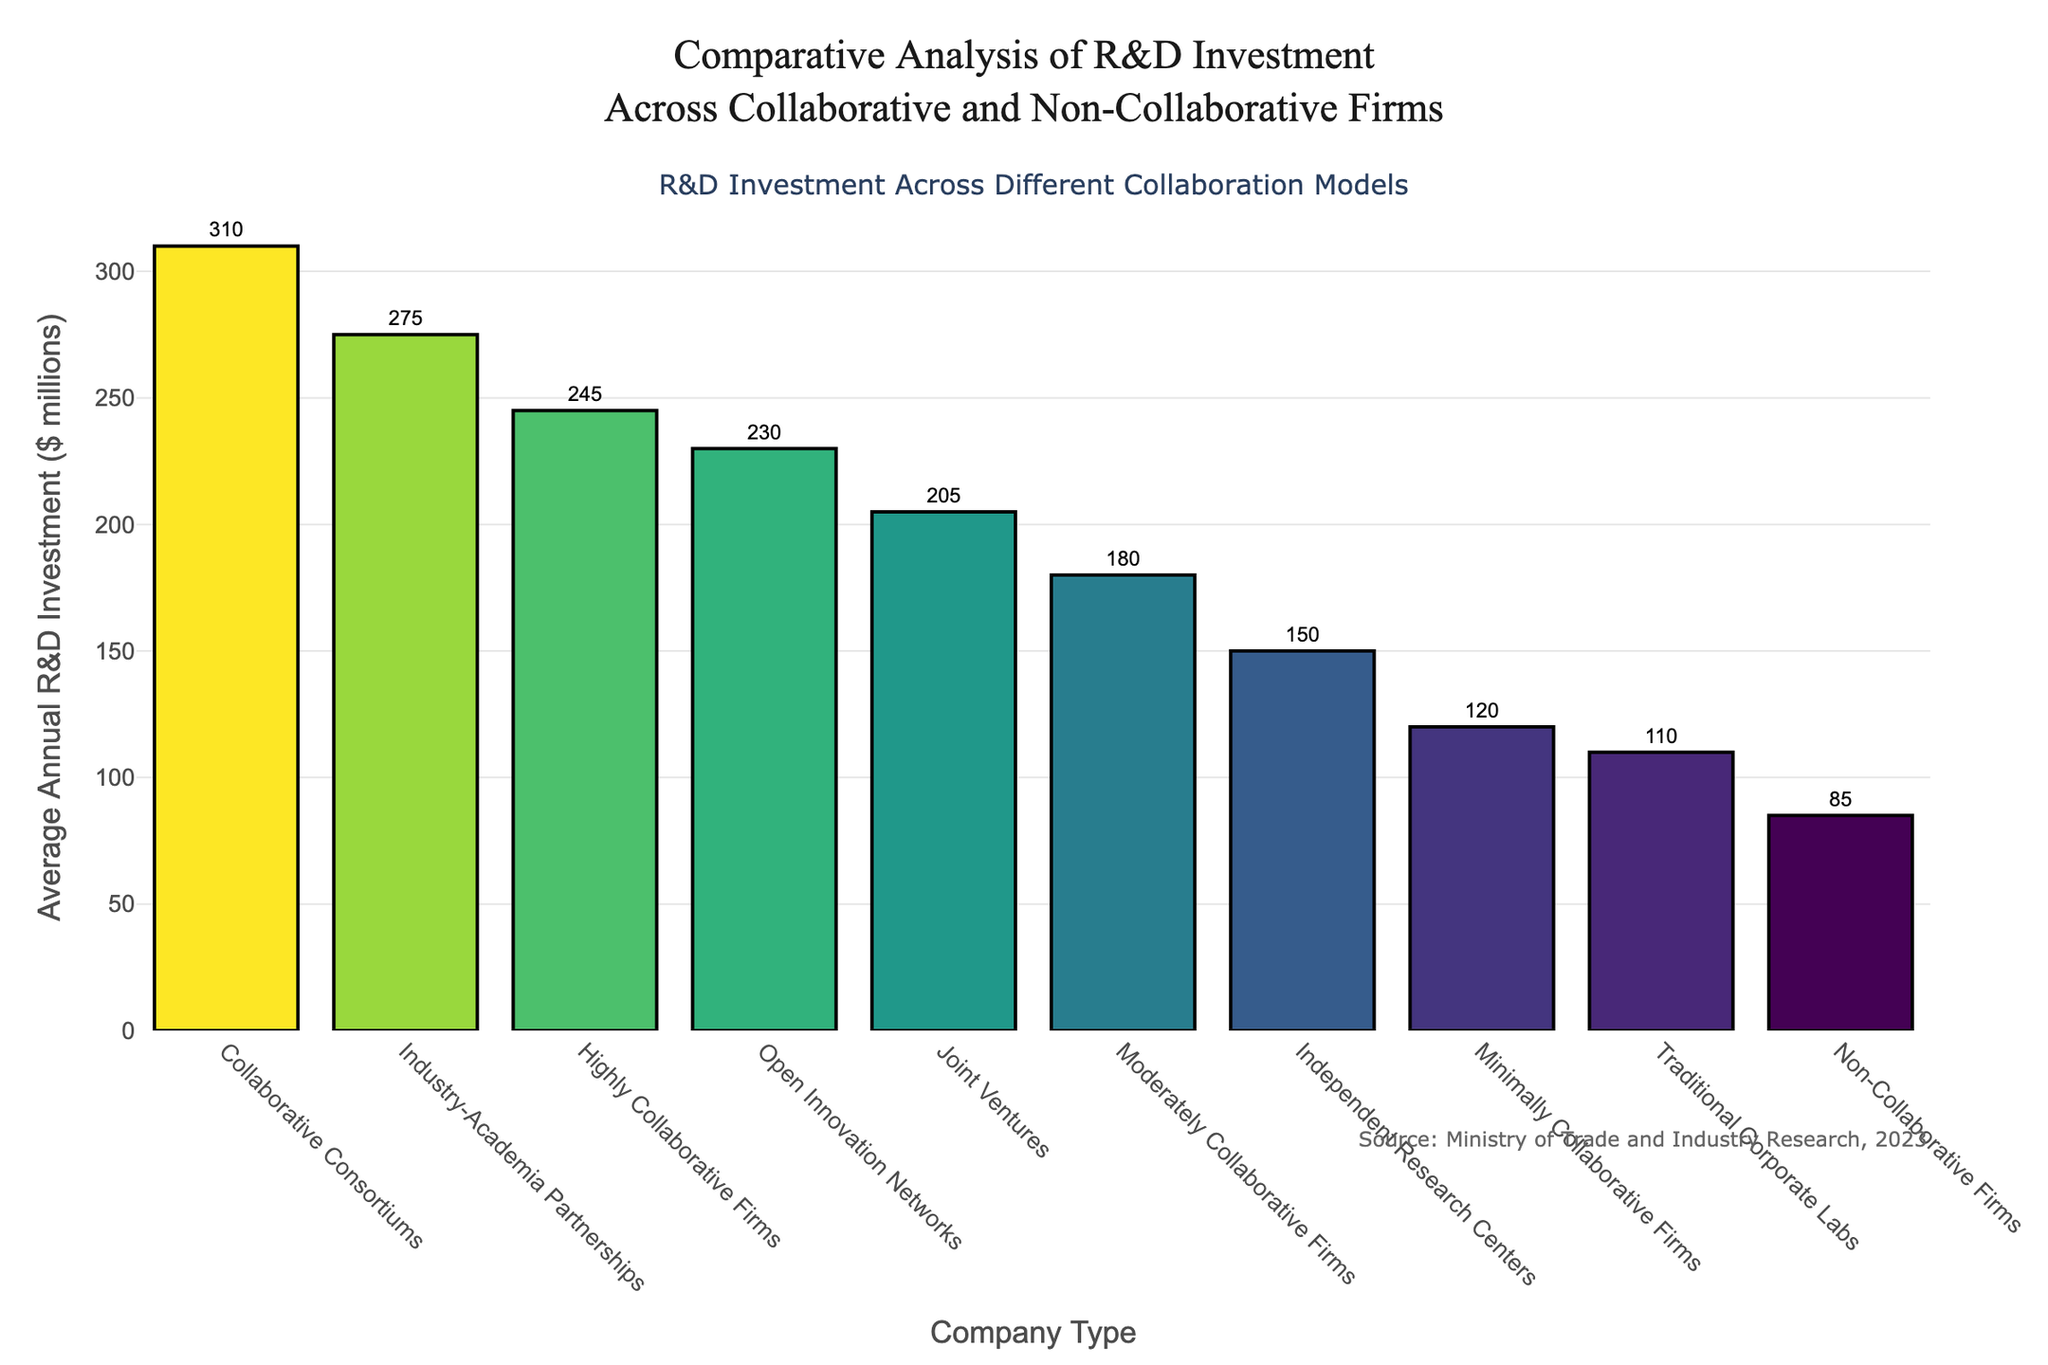What is the average annual R&D investment for Highly Collaborative Firms and Non-Collaborative Firms combined? First, note the R&D investments: Highly Collaborative Firms ($245M) and Non-Collaborative Firms ($85M). Add them together: $245M + $85M = $330M.
Answer: $330M Which company type has the highest annual R&D investment? Look for the tallest bar in the bar chart. Collaborative Consortiums at $310 million is the tallest.
Answer: Collaborative Consortiums By how much is the average annual R&D investment of Joint Ventures greater than Traditional Corporate Labs? Note the values for Joint Ventures ($205M) and Traditional Corporate Labs ($110M). Subtract the investment of Traditional Corporate Labs from Joint Ventures: $205M - $110M = $95M.
Answer: $95M Rank the company types from highest to lowest based on their average annual R&D investment. Identify and list the bars in descending order of height: 1) Collaborative Consortiums ($310M), 2) Industry-Academia Partnerships ($275M), 3) Highly Collaborative Firms ($245M), 4) Open Innovation Networks ($230M), 5) Joint Ventures ($205M), 6) Moderately Collaborative Firms ($180M), 7) Independent Research Centers ($150M), 8) Minimally Collaborative Firms ($120M), 9) Traditional Corporate Labs ($110M), 10) Non-Collaborative Firms ($85M).
Answer: Collaborative Consortiums, Industry-Academia Partnerships, Highly Collaborative Firms, Open Innovation Networks, Joint Ventures, Moderately Collaborative Firms, Independent Research Centers, Minimally Collaborative Firms, Traditional Corporate Labs, Non-Collaborative Firms What is the total R&D investment of all the collaborative company types combined? Summing the values: Collaborative Consortiums ($310M), Industry-Academia Partnerships ($275M), Highly Collaborative Firms ($245M), Open Innovation Networks ($230M), Joint Ventures ($205M), Moderately Collaborative Firms ($180M), Minimally Collaborative Firms ($120M) results in $310M + $275M + $245M + $230M + $205M + $180M + $120M = $1565M.
Answer: $1565M Compare the R&D investment of Independent Research Centers and Traditional Corporate Labs. Which one invests more, and by how much? Note the values for Independent Research Centers ($150M) and Traditional Corporate Labs ($110M). Since $150M is greater than $110M, subtract: $150M - $110M = $40M.
Answer: Independent Research Centers by $40M What is the difference in R&D investment between Highly Collaborative Firms and Minimally Collaborative Firms? Note the values for Highly Collaborative Firms ($245M) and Minimally Collaborative Firms ($120M). Subtract: $245M - $120M = $125M.
Answer: $125M Which firm type invests more in R&D: Industry-Academia Partnerships or Open Innovation Networks? By how much? Compare Industry-Academia Partnerships ($275M) and Open Innovation Networks ($230M). Subtract: $275M - $230M = $45M.
Answer: Industry-Academia Partnerships by $45M 